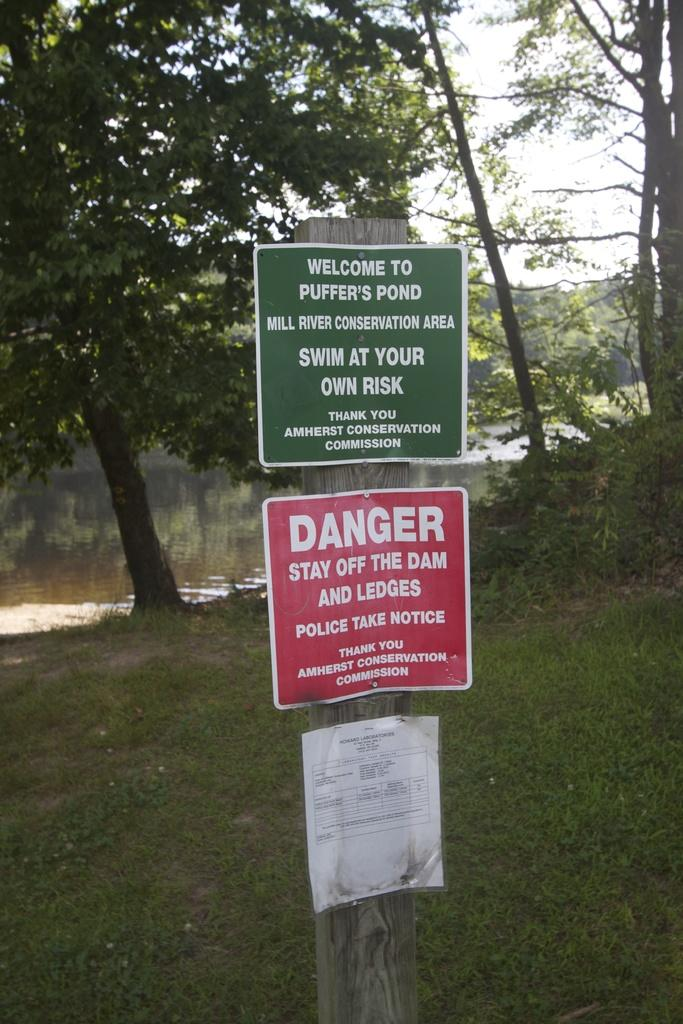What is the wooden pole with words used for in the image? The wooden pole with words is likely a sign or marker of some kind. What can be seen in the water in the image? The facts do not specify what can be seen in the water, so we cannot answer that question definitively. What type of vegetation is present in the image? Trees and grass are visible in the image. What is visible in the background of the image? The sky is visible in the background of the image. How many horses are swimming in the water in the image? There are no horses present in the image; it features a wooden pole with words, water, trees, grass, and the sky. Is there any smoke coming from the wooden pole in the image? There is no smoke present in the image; it only features a wooden pole with words, water, trees, grass, and the sky. 